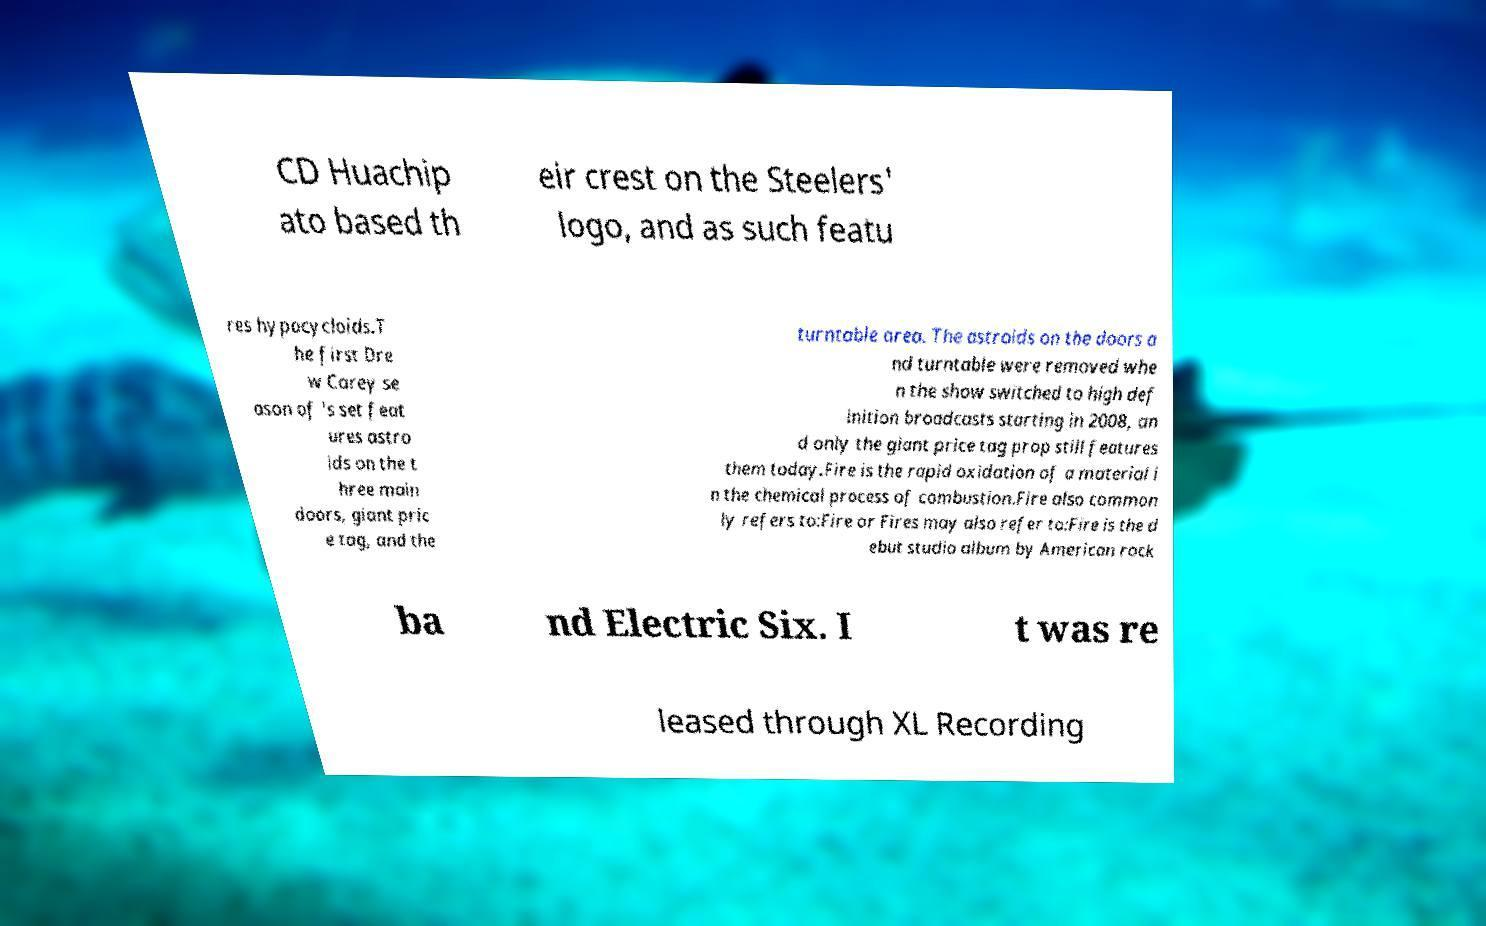Can you read and provide the text displayed in the image?This photo seems to have some interesting text. Can you extract and type it out for me? CD Huachip ato based th eir crest on the Steelers' logo, and as such featu res hypocycloids.T he first Dre w Carey se ason of 's set feat ures astro ids on the t hree main doors, giant pric e tag, and the turntable area. The astroids on the doors a nd turntable were removed whe n the show switched to high def inition broadcasts starting in 2008, an d only the giant price tag prop still features them today.Fire is the rapid oxidation of a material i n the chemical process of combustion.Fire also common ly refers to:Fire or Fires may also refer to:Fire is the d ebut studio album by American rock ba nd Electric Six. I t was re leased through XL Recording 